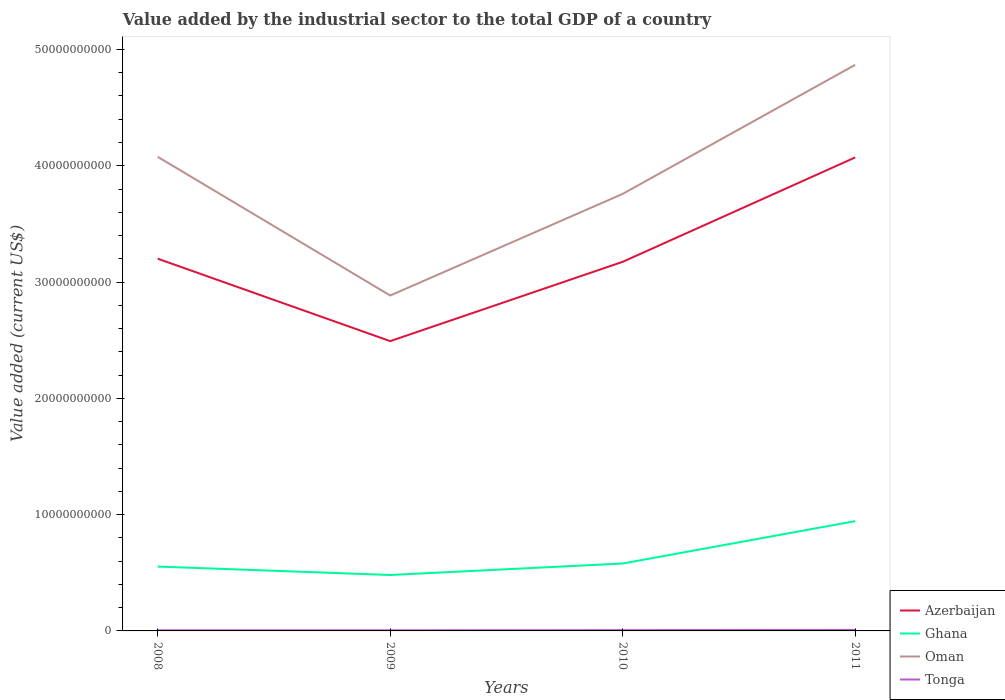Is the number of lines equal to the number of legend labels?
Provide a short and direct response. Yes. Across all years, what is the maximum value added by the industrial sector to the total GDP in Oman?
Make the answer very short. 2.88e+1. In which year was the value added by the industrial sector to the total GDP in Tonga maximum?
Keep it short and to the point. 2008. What is the total value added by the industrial sector to the total GDP in Ghana in the graph?
Your answer should be compact. 7.25e+08. What is the difference between the highest and the second highest value added by the industrial sector to the total GDP in Azerbaijan?
Offer a very short reply. 1.58e+1. What is the difference between the highest and the lowest value added by the industrial sector to the total GDP in Azerbaijan?
Ensure brevity in your answer.  1. Is the value added by the industrial sector to the total GDP in Ghana strictly greater than the value added by the industrial sector to the total GDP in Azerbaijan over the years?
Keep it short and to the point. Yes. How many lines are there?
Your response must be concise. 4. How many years are there in the graph?
Your answer should be compact. 4. What is the difference between two consecutive major ticks on the Y-axis?
Your answer should be very brief. 1.00e+1. Does the graph contain any zero values?
Keep it short and to the point. No. Does the graph contain grids?
Give a very brief answer. No. Where does the legend appear in the graph?
Offer a very short reply. Bottom right. How many legend labels are there?
Your response must be concise. 4. How are the legend labels stacked?
Make the answer very short. Vertical. What is the title of the graph?
Give a very brief answer. Value added by the industrial sector to the total GDP of a country. Does "Vanuatu" appear as one of the legend labels in the graph?
Keep it short and to the point. No. What is the label or title of the X-axis?
Your response must be concise. Years. What is the label or title of the Y-axis?
Ensure brevity in your answer.  Value added (current US$). What is the Value added (current US$) of Azerbaijan in 2008?
Your answer should be compact. 3.20e+1. What is the Value added (current US$) in Ghana in 2008?
Offer a terse response. 5.53e+09. What is the Value added (current US$) in Oman in 2008?
Keep it short and to the point. 4.08e+1. What is the Value added (current US$) of Tonga in 2008?
Ensure brevity in your answer.  5.28e+07. What is the Value added (current US$) in Azerbaijan in 2009?
Provide a short and direct response. 2.49e+1. What is the Value added (current US$) in Ghana in 2009?
Give a very brief answer. 4.81e+09. What is the Value added (current US$) in Oman in 2009?
Your answer should be compact. 2.88e+1. What is the Value added (current US$) in Tonga in 2009?
Give a very brief answer. 5.43e+07. What is the Value added (current US$) of Azerbaijan in 2010?
Your answer should be very brief. 3.17e+1. What is the Value added (current US$) of Ghana in 2010?
Your response must be concise. 5.80e+09. What is the Value added (current US$) in Oman in 2010?
Ensure brevity in your answer.  3.76e+1. What is the Value added (current US$) in Tonga in 2010?
Make the answer very short. 6.71e+07. What is the Value added (current US$) in Azerbaijan in 2011?
Your response must be concise. 4.07e+1. What is the Value added (current US$) in Ghana in 2011?
Offer a very short reply. 9.44e+09. What is the Value added (current US$) of Oman in 2011?
Your answer should be compact. 4.87e+1. What is the Value added (current US$) of Tonga in 2011?
Make the answer very short. 8.54e+07. Across all years, what is the maximum Value added (current US$) in Azerbaijan?
Make the answer very short. 4.07e+1. Across all years, what is the maximum Value added (current US$) of Ghana?
Your response must be concise. 9.44e+09. Across all years, what is the maximum Value added (current US$) in Oman?
Keep it short and to the point. 4.87e+1. Across all years, what is the maximum Value added (current US$) of Tonga?
Make the answer very short. 8.54e+07. Across all years, what is the minimum Value added (current US$) in Azerbaijan?
Offer a very short reply. 2.49e+1. Across all years, what is the minimum Value added (current US$) of Ghana?
Keep it short and to the point. 4.81e+09. Across all years, what is the minimum Value added (current US$) in Oman?
Make the answer very short. 2.88e+1. Across all years, what is the minimum Value added (current US$) in Tonga?
Ensure brevity in your answer.  5.28e+07. What is the total Value added (current US$) in Azerbaijan in the graph?
Your answer should be compact. 1.29e+11. What is the total Value added (current US$) in Ghana in the graph?
Ensure brevity in your answer.  2.56e+1. What is the total Value added (current US$) in Oman in the graph?
Provide a short and direct response. 1.56e+11. What is the total Value added (current US$) in Tonga in the graph?
Make the answer very short. 2.60e+08. What is the difference between the Value added (current US$) in Azerbaijan in 2008 and that in 2009?
Offer a terse response. 7.09e+09. What is the difference between the Value added (current US$) in Ghana in 2008 and that in 2009?
Keep it short and to the point. 7.25e+08. What is the difference between the Value added (current US$) in Oman in 2008 and that in 2009?
Offer a terse response. 1.19e+1. What is the difference between the Value added (current US$) of Tonga in 2008 and that in 2009?
Offer a very short reply. -1.49e+06. What is the difference between the Value added (current US$) of Azerbaijan in 2008 and that in 2010?
Make the answer very short. 2.69e+08. What is the difference between the Value added (current US$) in Ghana in 2008 and that in 2010?
Keep it short and to the point. -2.62e+08. What is the difference between the Value added (current US$) in Oman in 2008 and that in 2010?
Your response must be concise. 3.19e+09. What is the difference between the Value added (current US$) of Tonga in 2008 and that in 2010?
Give a very brief answer. -1.43e+07. What is the difference between the Value added (current US$) of Azerbaijan in 2008 and that in 2011?
Your answer should be compact. -8.71e+09. What is the difference between the Value added (current US$) of Ghana in 2008 and that in 2011?
Your answer should be very brief. -3.91e+09. What is the difference between the Value added (current US$) in Oman in 2008 and that in 2011?
Your response must be concise. -7.91e+09. What is the difference between the Value added (current US$) of Tonga in 2008 and that in 2011?
Your answer should be very brief. -3.27e+07. What is the difference between the Value added (current US$) of Azerbaijan in 2009 and that in 2010?
Provide a succinct answer. -6.82e+09. What is the difference between the Value added (current US$) in Ghana in 2009 and that in 2010?
Ensure brevity in your answer.  -9.87e+08. What is the difference between the Value added (current US$) of Oman in 2009 and that in 2010?
Ensure brevity in your answer.  -8.74e+09. What is the difference between the Value added (current US$) of Tonga in 2009 and that in 2010?
Give a very brief answer. -1.28e+07. What is the difference between the Value added (current US$) in Azerbaijan in 2009 and that in 2011?
Make the answer very short. -1.58e+1. What is the difference between the Value added (current US$) of Ghana in 2009 and that in 2011?
Ensure brevity in your answer.  -4.63e+09. What is the difference between the Value added (current US$) of Oman in 2009 and that in 2011?
Your answer should be compact. -1.98e+1. What is the difference between the Value added (current US$) in Tonga in 2009 and that in 2011?
Ensure brevity in your answer.  -3.12e+07. What is the difference between the Value added (current US$) in Azerbaijan in 2010 and that in 2011?
Give a very brief answer. -8.98e+09. What is the difference between the Value added (current US$) of Ghana in 2010 and that in 2011?
Ensure brevity in your answer.  -3.65e+09. What is the difference between the Value added (current US$) of Oman in 2010 and that in 2011?
Give a very brief answer. -1.11e+1. What is the difference between the Value added (current US$) in Tonga in 2010 and that in 2011?
Your answer should be very brief. -1.83e+07. What is the difference between the Value added (current US$) in Azerbaijan in 2008 and the Value added (current US$) in Ghana in 2009?
Your answer should be very brief. 2.72e+1. What is the difference between the Value added (current US$) in Azerbaijan in 2008 and the Value added (current US$) in Oman in 2009?
Your response must be concise. 3.17e+09. What is the difference between the Value added (current US$) of Azerbaijan in 2008 and the Value added (current US$) of Tonga in 2009?
Keep it short and to the point. 3.20e+1. What is the difference between the Value added (current US$) of Ghana in 2008 and the Value added (current US$) of Oman in 2009?
Make the answer very short. -2.33e+1. What is the difference between the Value added (current US$) of Ghana in 2008 and the Value added (current US$) of Tonga in 2009?
Provide a short and direct response. 5.48e+09. What is the difference between the Value added (current US$) of Oman in 2008 and the Value added (current US$) of Tonga in 2009?
Your response must be concise. 4.07e+1. What is the difference between the Value added (current US$) of Azerbaijan in 2008 and the Value added (current US$) of Ghana in 2010?
Provide a short and direct response. 2.62e+1. What is the difference between the Value added (current US$) of Azerbaijan in 2008 and the Value added (current US$) of Oman in 2010?
Offer a terse response. -5.57e+09. What is the difference between the Value added (current US$) of Azerbaijan in 2008 and the Value added (current US$) of Tonga in 2010?
Your response must be concise. 3.19e+1. What is the difference between the Value added (current US$) of Ghana in 2008 and the Value added (current US$) of Oman in 2010?
Your answer should be compact. -3.20e+1. What is the difference between the Value added (current US$) in Ghana in 2008 and the Value added (current US$) in Tonga in 2010?
Your answer should be compact. 5.47e+09. What is the difference between the Value added (current US$) in Oman in 2008 and the Value added (current US$) in Tonga in 2010?
Your answer should be compact. 4.07e+1. What is the difference between the Value added (current US$) in Azerbaijan in 2008 and the Value added (current US$) in Ghana in 2011?
Your answer should be compact. 2.26e+1. What is the difference between the Value added (current US$) of Azerbaijan in 2008 and the Value added (current US$) of Oman in 2011?
Offer a terse response. -1.67e+1. What is the difference between the Value added (current US$) in Azerbaijan in 2008 and the Value added (current US$) in Tonga in 2011?
Make the answer very short. 3.19e+1. What is the difference between the Value added (current US$) in Ghana in 2008 and the Value added (current US$) in Oman in 2011?
Offer a very short reply. -4.31e+1. What is the difference between the Value added (current US$) in Ghana in 2008 and the Value added (current US$) in Tonga in 2011?
Offer a very short reply. 5.45e+09. What is the difference between the Value added (current US$) in Oman in 2008 and the Value added (current US$) in Tonga in 2011?
Your answer should be compact. 4.07e+1. What is the difference between the Value added (current US$) of Azerbaijan in 2009 and the Value added (current US$) of Ghana in 2010?
Offer a terse response. 1.91e+1. What is the difference between the Value added (current US$) in Azerbaijan in 2009 and the Value added (current US$) in Oman in 2010?
Your answer should be compact. -1.27e+1. What is the difference between the Value added (current US$) in Azerbaijan in 2009 and the Value added (current US$) in Tonga in 2010?
Keep it short and to the point. 2.49e+1. What is the difference between the Value added (current US$) of Ghana in 2009 and the Value added (current US$) of Oman in 2010?
Your answer should be compact. -3.28e+1. What is the difference between the Value added (current US$) in Ghana in 2009 and the Value added (current US$) in Tonga in 2010?
Keep it short and to the point. 4.74e+09. What is the difference between the Value added (current US$) in Oman in 2009 and the Value added (current US$) in Tonga in 2010?
Make the answer very short. 2.88e+1. What is the difference between the Value added (current US$) of Azerbaijan in 2009 and the Value added (current US$) of Ghana in 2011?
Provide a succinct answer. 1.55e+1. What is the difference between the Value added (current US$) of Azerbaijan in 2009 and the Value added (current US$) of Oman in 2011?
Provide a succinct answer. -2.38e+1. What is the difference between the Value added (current US$) in Azerbaijan in 2009 and the Value added (current US$) in Tonga in 2011?
Offer a terse response. 2.48e+1. What is the difference between the Value added (current US$) of Ghana in 2009 and the Value added (current US$) of Oman in 2011?
Ensure brevity in your answer.  -4.39e+1. What is the difference between the Value added (current US$) of Ghana in 2009 and the Value added (current US$) of Tonga in 2011?
Provide a short and direct response. 4.72e+09. What is the difference between the Value added (current US$) in Oman in 2009 and the Value added (current US$) in Tonga in 2011?
Offer a terse response. 2.88e+1. What is the difference between the Value added (current US$) of Azerbaijan in 2010 and the Value added (current US$) of Ghana in 2011?
Your answer should be very brief. 2.23e+1. What is the difference between the Value added (current US$) in Azerbaijan in 2010 and the Value added (current US$) in Oman in 2011?
Make the answer very short. -1.69e+1. What is the difference between the Value added (current US$) of Azerbaijan in 2010 and the Value added (current US$) of Tonga in 2011?
Keep it short and to the point. 3.17e+1. What is the difference between the Value added (current US$) of Ghana in 2010 and the Value added (current US$) of Oman in 2011?
Provide a short and direct response. -4.29e+1. What is the difference between the Value added (current US$) in Ghana in 2010 and the Value added (current US$) in Tonga in 2011?
Give a very brief answer. 5.71e+09. What is the difference between the Value added (current US$) in Oman in 2010 and the Value added (current US$) in Tonga in 2011?
Offer a terse response. 3.75e+1. What is the average Value added (current US$) in Azerbaijan per year?
Give a very brief answer. 3.23e+1. What is the average Value added (current US$) of Ghana per year?
Give a very brief answer. 6.40e+09. What is the average Value added (current US$) of Oman per year?
Your answer should be compact. 3.90e+1. What is the average Value added (current US$) in Tonga per year?
Offer a very short reply. 6.49e+07. In the year 2008, what is the difference between the Value added (current US$) of Azerbaijan and Value added (current US$) of Ghana?
Your answer should be very brief. 2.65e+1. In the year 2008, what is the difference between the Value added (current US$) of Azerbaijan and Value added (current US$) of Oman?
Your answer should be compact. -8.76e+09. In the year 2008, what is the difference between the Value added (current US$) in Azerbaijan and Value added (current US$) in Tonga?
Provide a short and direct response. 3.20e+1. In the year 2008, what is the difference between the Value added (current US$) of Ghana and Value added (current US$) of Oman?
Give a very brief answer. -3.52e+1. In the year 2008, what is the difference between the Value added (current US$) of Ghana and Value added (current US$) of Tonga?
Your answer should be very brief. 5.48e+09. In the year 2008, what is the difference between the Value added (current US$) of Oman and Value added (current US$) of Tonga?
Ensure brevity in your answer.  4.07e+1. In the year 2009, what is the difference between the Value added (current US$) of Azerbaijan and Value added (current US$) of Ghana?
Your answer should be compact. 2.01e+1. In the year 2009, what is the difference between the Value added (current US$) of Azerbaijan and Value added (current US$) of Oman?
Ensure brevity in your answer.  -3.92e+09. In the year 2009, what is the difference between the Value added (current US$) of Azerbaijan and Value added (current US$) of Tonga?
Your answer should be compact. 2.49e+1. In the year 2009, what is the difference between the Value added (current US$) of Ghana and Value added (current US$) of Oman?
Provide a short and direct response. -2.40e+1. In the year 2009, what is the difference between the Value added (current US$) of Ghana and Value added (current US$) of Tonga?
Make the answer very short. 4.76e+09. In the year 2009, what is the difference between the Value added (current US$) of Oman and Value added (current US$) of Tonga?
Offer a terse response. 2.88e+1. In the year 2010, what is the difference between the Value added (current US$) of Azerbaijan and Value added (current US$) of Ghana?
Your answer should be very brief. 2.59e+1. In the year 2010, what is the difference between the Value added (current US$) of Azerbaijan and Value added (current US$) of Oman?
Ensure brevity in your answer.  -5.84e+09. In the year 2010, what is the difference between the Value added (current US$) in Azerbaijan and Value added (current US$) in Tonga?
Ensure brevity in your answer.  3.17e+1. In the year 2010, what is the difference between the Value added (current US$) of Ghana and Value added (current US$) of Oman?
Your answer should be compact. -3.18e+1. In the year 2010, what is the difference between the Value added (current US$) of Ghana and Value added (current US$) of Tonga?
Provide a succinct answer. 5.73e+09. In the year 2010, what is the difference between the Value added (current US$) in Oman and Value added (current US$) in Tonga?
Ensure brevity in your answer.  3.75e+1. In the year 2011, what is the difference between the Value added (current US$) in Azerbaijan and Value added (current US$) in Ghana?
Offer a terse response. 3.13e+1. In the year 2011, what is the difference between the Value added (current US$) in Azerbaijan and Value added (current US$) in Oman?
Provide a succinct answer. -7.96e+09. In the year 2011, what is the difference between the Value added (current US$) in Azerbaijan and Value added (current US$) in Tonga?
Your answer should be very brief. 4.06e+1. In the year 2011, what is the difference between the Value added (current US$) in Ghana and Value added (current US$) in Oman?
Ensure brevity in your answer.  -3.92e+1. In the year 2011, what is the difference between the Value added (current US$) of Ghana and Value added (current US$) of Tonga?
Your answer should be very brief. 9.36e+09. In the year 2011, what is the difference between the Value added (current US$) in Oman and Value added (current US$) in Tonga?
Keep it short and to the point. 4.86e+1. What is the ratio of the Value added (current US$) in Azerbaijan in 2008 to that in 2009?
Give a very brief answer. 1.28. What is the ratio of the Value added (current US$) in Ghana in 2008 to that in 2009?
Offer a very short reply. 1.15. What is the ratio of the Value added (current US$) in Oman in 2008 to that in 2009?
Your answer should be compact. 1.41. What is the ratio of the Value added (current US$) in Tonga in 2008 to that in 2009?
Keep it short and to the point. 0.97. What is the ratio of the Value added (current US$) in Azerbaijan in 2008 to that in 2010?
Provide a short and direct response. 1.01. What is the ratio of the Value added (current US$) of Ghana in 2008 to that in 2010?
Offer a terse response. 0.95. What is the ratio of the Value added (current US$) of Oman in 2008 to that in 2010?
Your answer should be very brief. 1.08. What is the ratio of the Value added (current US$) in Tonga in 2008 to that in 2010?
Provide a succinct answer. 0.79. What is the ratio of the Value added (current US$) in Azerbaijan in 2008 to that in 2011?
Ensure brevity in your answer.  0.79. What is the ratio of the Value added (current US$) of Ghana in 2008 to that in 2011?
Give a very brief answer. 0.59. What is the ratio of the Value added (current US$) of Oman in 2008 to that in 2011?
Give a very brief answer. 0.84. What is the ratio of the Value added (current US$) in Tonga in 2008 to that in 2011?
Ensure brevity in your answer.  0.62. What is the ratio of the Value added (current US$) in Azerbaijan in 2009 to that in 2010?
Offer a terse response. 0.79. What is the ratio of the Value added (current US$) of Ghana in 2009 to that in 2010?
Ensure brevity in your answer.  0.83. What is the ratio of the Value added (current US$) of Oman in 2009 to that in 2010?
Your answer should be very brief. 0.77. What is the ratio of the Value added (current US$) of Tonga in 2009 to that in 2010?
Offer a terse response. 0.81. What is the ratio of the Value added (current US$) of Azerbaijan in 2009 to that in 2011?
Give a very brief answer. 0.61. What is the ratio of the Value added (current US$) in Ghana in 2009 to that in 2011?
Offer a very short reply. 0.51. What is the ratio of the Value added (current US$) of Oman in 2009 to that in 2011?
Offer a terse response. 0.59. What is the ratio of the Value added (current US$) of Tonga in 2009 to that in 2011?
Offer a very short reply. 0.64. What is the ratio of the Value added (current US$) in Azerbaijan in 2010 to that in 2011?
Provide a short and direct response. 0.78. What is the ratio of the Value added (current US$) of Ghana in 2010 to that in 2011?
Give a very brief answer. 0.61. What is the ratio of the Value added (current US$) in Oman in 2010 to that in 2011?
Give a very brief answer. 0.77. What is the ratio of the Value added (current US$) in Tonga in 2010 to that in 2011?
Offer a very short reply. 0.79. What is the difference between the highest and the second highest Value added (current US$) of Azerbaijan?
Provide a succinct answer. 8.71e+09. What is the difference between the highest and the second highest Value added (current US$) in Ghana?
Your answer should be compact. 3.65e+09. What is the difference between the highest and the second highest Value added (current US$) in Oman?
Your answer should be compact. 7.91e+09. What is the difference between the highest and the second highest Value added (current US$) in Tonga?
Ensure brevity in your answer.  1.83e+07. What is the difference between the highest and the lowest Value added (current US$) of Azerbaijan?
Keep it short and to the point. 1.58e+1. What is the difference between the highest and the lowest Value added (current US$) in Ghana?
Provide a short and direct response. 4.63e+09. What is the difference between the highest and the lowest Value added (current US$) in Oman?
Provide a short and direct response. 1.98e+1. What is the difference between the highest and the lowest Value added (current US$) in Tonga?
Give a very brief answer. 3.27e+07. 